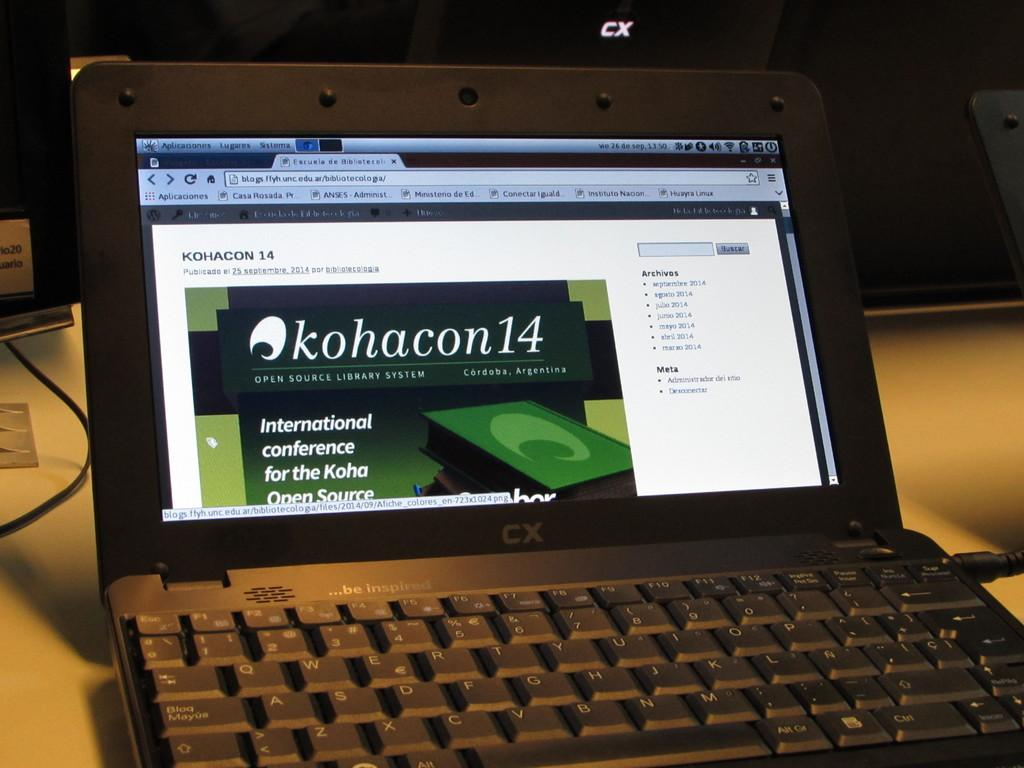<image>
Create a compact narrative representing the image presented. A laptop that is turned on, that made by a brand with a "CX" logo. 